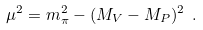Convert formula to latex. <formula><loc_0><loc_0><loc_500><loc_500>\mu ^ { 2 } = m _ { \pi } ^ { 2 } - ( M _ { V } - M _ { P } ) ^ { 2 } \ .</formula> 